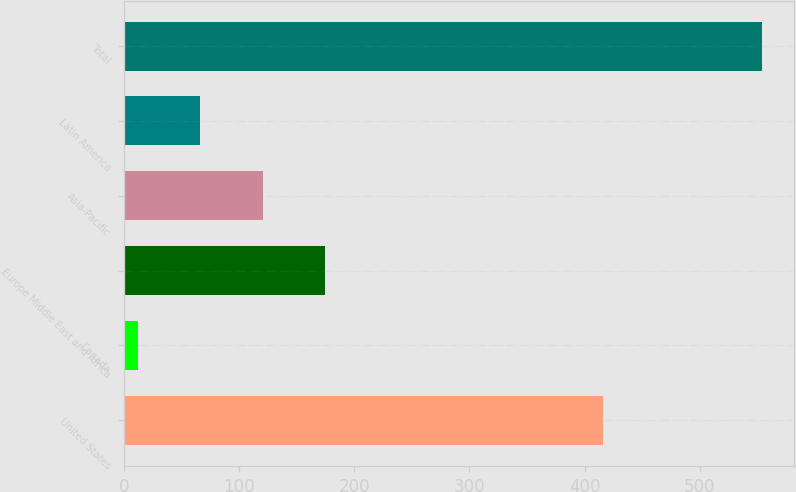<chart> <loc_0><loc_0><loc_500><loc_500><bar_chart><fcel>United States<fcel>Canada<fcel>Europe Middle East and Africa<fcel>Asia-Pacific<fcel>Latin America<fcel>Total<nl><fcel>416.4<fcel>12.4<fcel>174.82<fcel>120.68<fcel>66.54<fcel>553.8<nl></chart> 